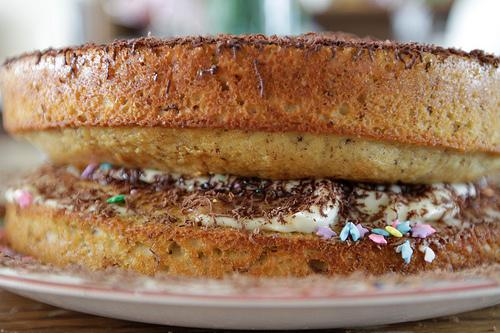Question: where is this picture taken?
Choices:
A. In the yard.
B. In the swimming pool.
C. At a table.
D. On the sofa.
Answer with the letter. Answer: C Question: what is the plate sitting on?
Choices:
A. A tray.
B. A bed.
C. A table.
D. A sofa.
Answer with the letter. Answer: C 